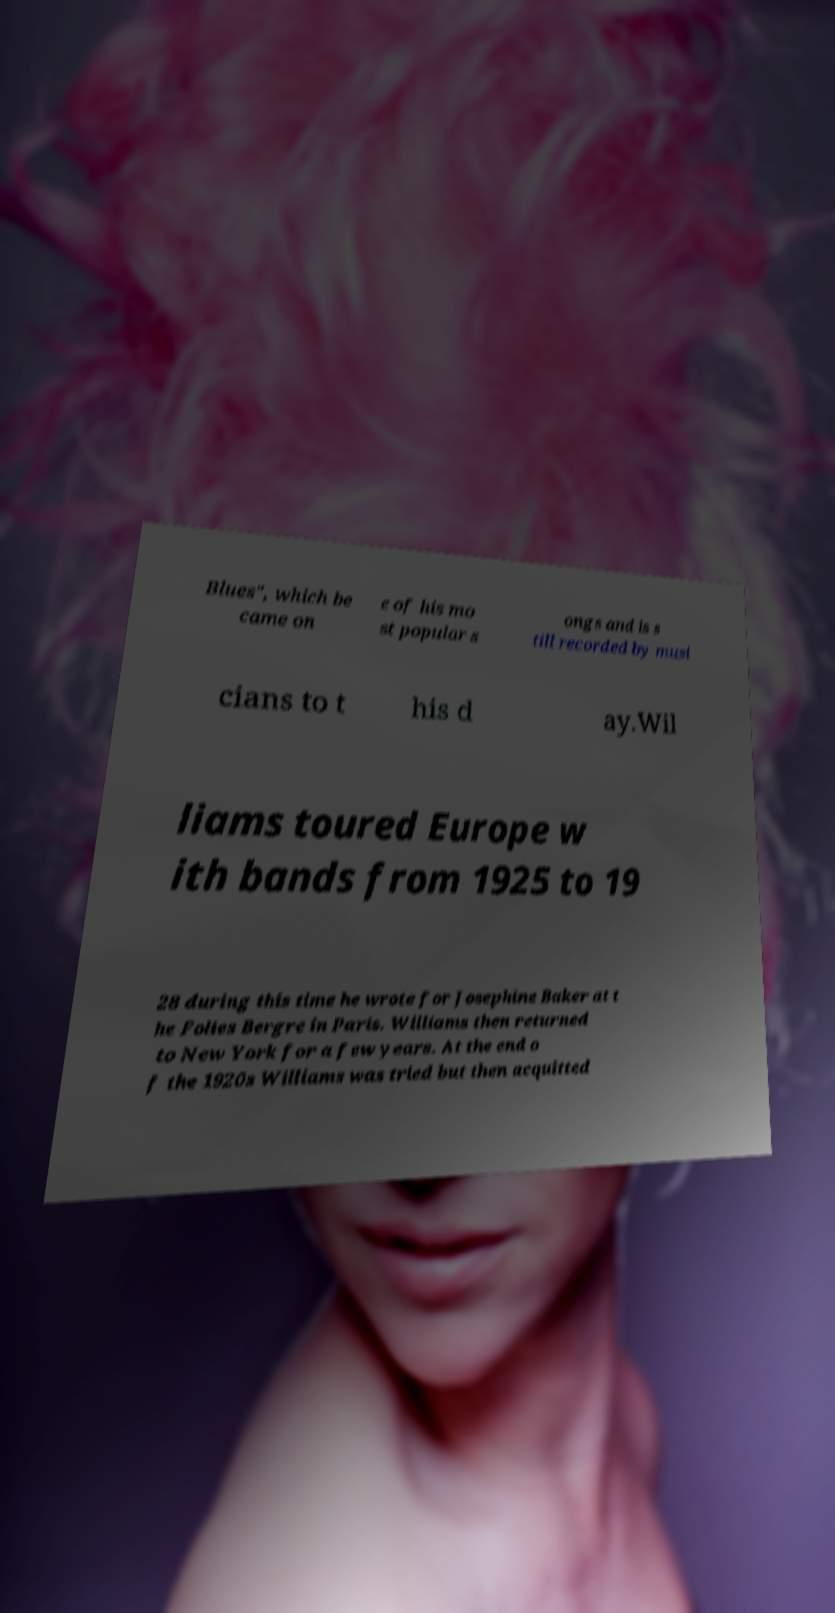For documentation purposes, I need the text within this image transcribed. Could you provide that? Blues", which be came on e of his mo st popular s ongs and is s till recorded by musi cians to t his d ay.Wil liams toured Europe w ith bands from 1925 to 19 28 during this time he wrote for Josephine Baker at t he Folies Bergre in Paris. Williams then returned to New York for a few years. At the end o f the 1920s Williams was tried but then acquitted 